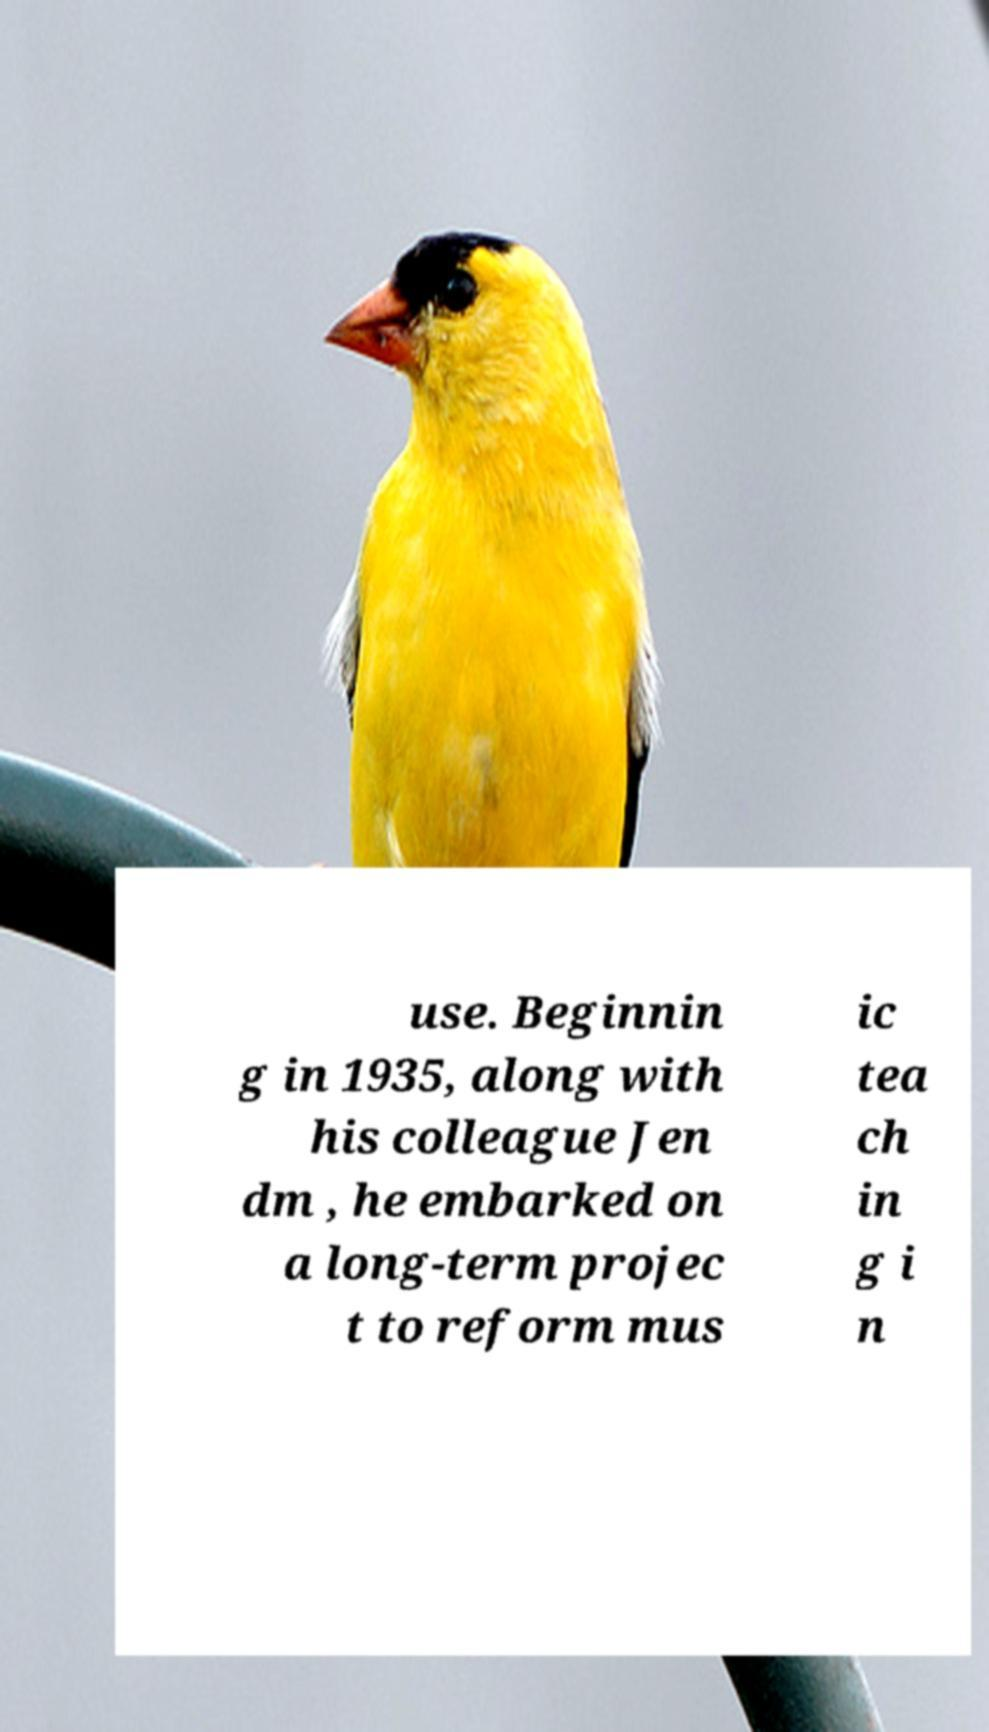Please identify and transcribe the text found in this image. use. Beginnin g in 1935, along with his colleague Jen dm , he embarked on a long-term projec t to reform mus ic tea ch in g i n 